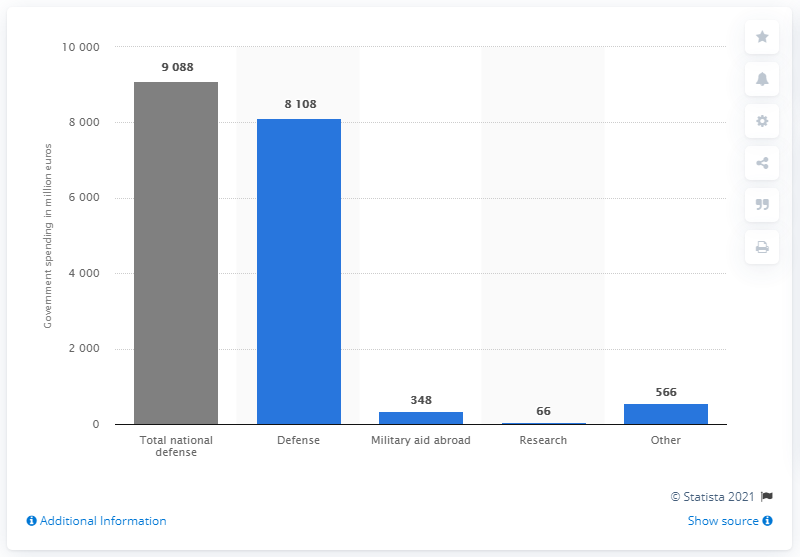Indicate a few pertinent items in this graphic. In 2018, a total of $348 million was spent on military aid abroad. 